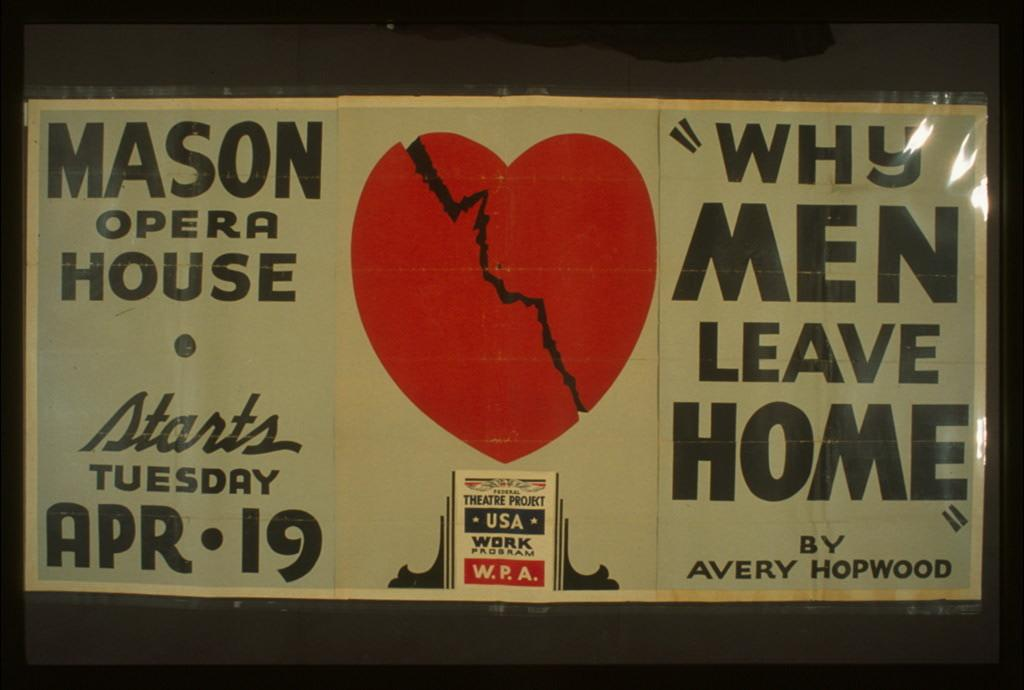<image>
Provide a brief description of the given image. Sign that says "Why Men Leave Home" next to a picture of a heart. 